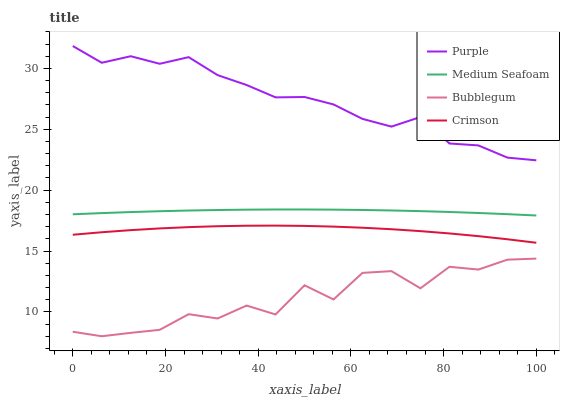Does Bubblegum have the minimum area under the curve?
Answer yes or no. Yes. Does Purple have the maximum area under the curve?
Answer yes or no. Yes. Does Crimson have the minimum area under the curve?
Answer yes or no. No. Does Crimson have the maximum area under the curve?
Answer yes or no. No. Is Medium Seafoam the smoothest?
Answer yes or no. Yes. Is Bubblegum the roughest?
Answer yes or no. Yes. Is Crimson the smoothest?
Answer yes or no. No. Is Crimson the roughest?
Answer yes or no. No. Does Bubblegum have the lowest value?
Answer yes or no. Yes. Does Crimson have the lowest value?
Answer yes or no. No. Does Purple have the highest value?
Answer yes or no. Yes. Does Crimson have the highest value?
Answer yes or no. No. Is Bubblegum less than Medium Seafoam?
Answer yes or no. Yes. Is Medium Seafoam greater than Bubblegum?
Answer yes or no. Yes. Does Bubblegum intersect Medium Seafoam?
Answer yes or no. No. 